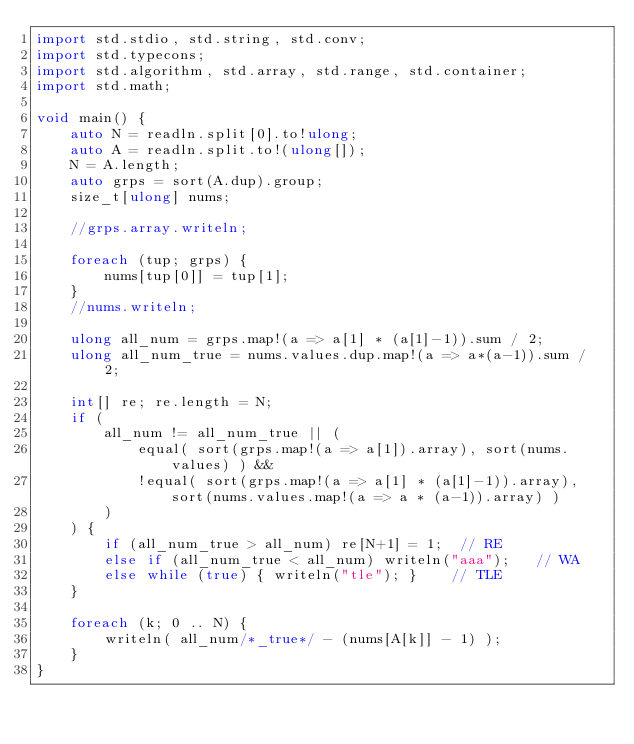Convert code to text. <code><loc_0><loc_0><loc_500><loc_500><_D_>import std.stdio, std.string, std.conv;
import std.typecons;
import std.algorithm, std.array, std.range, std.container;
import std.math;

void main() {
    auto N = readln.split[0].to!ulong;
    auto A = readln.split.to!(ulong[]);
    N = A.length;
    auto grps = sort(A.dup).group;
    size_t[ulong] nums;
    
    //grps.array.writeln;
    
    foreach (tup; grps) {
        nums[tup[0]] = tup[1];
    }
    //nums.writeln; 
    
    ulong all_num = grps.map!(a => a[1] * (a[1]-1)).sum / 2;
    ulong all_num_true = nums.values.dup.map!(a => a*(a-1)).sum / 2;
    
    int[] re; re.length = N;
    if (
        all_num != all_num_true || (
            equal( sort(grps.map!(a => a[1]).array), sort(nums.values) ) &&
            !equal( sort(grps.map!(a => a[1] * (a[1]-1)).array), sort(nums.values.map!(a => a * (a-1)).array) )
        )
    ) {
        if (all_num_true > all_num) re[N+1] = 1;  // RE
        else if (all_num_true < all_num) writeln("aaa");   // WA
        else while (true) { writeln("tle"); }    // TLE
    }
    
    foreach (k; 0 .. N) {
        writeln( all_num/*_true*/ - (nums[A[k]] - 1) );
    }
}

</code> 